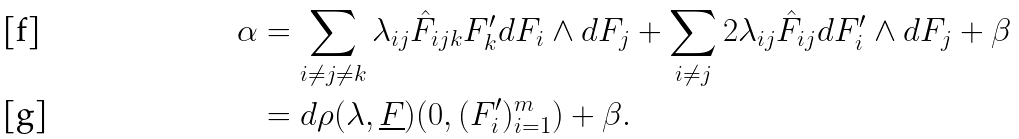<formula> <loc_0><loc_0><loc_500><loc_500>\alpha & = \sum _ { i \ne j \ne k } \lambda _ { i j } \hat { F } _ { i j k } F _ { k } ^ { \prime } d F _ { i } \wedge d F _ { j } + \sum _ { i \ne j } 2 \lambda _ { i j } \hat { F } _ { i j } d F _ { i } ^ { \prime } \wedge d F _ { j } + \beta \\ & = d \rho ( \lambda , \underline { F } ) ( 0 , ( F _ { i } ^ { \prime } ) _ { i = 1 } ^ { m } ) + \beta .</formula> 